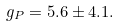Convert formula to latex. <formula><loc_0><loc_0><loc_500><loc_500>g _ { P } = 5 . 6 \pm 4 . 1 .</formula> 